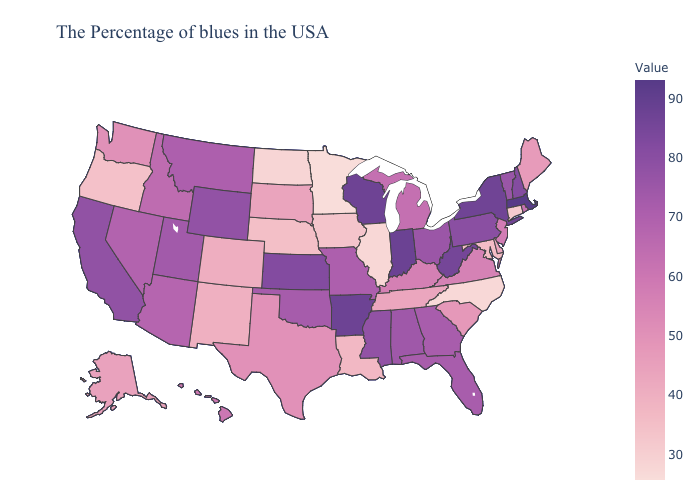Among the states that border Washington , does Oregon have the highest value?
Keep it brief. No. Does the map have missing data?
Quick response, please. No. Among the states that border Colorado , does Nebraska have the lowest value?
Be succinct. Yes. Which states have the lowest value in the South?
Quick response, please. North Carolina. Which states have the lowest value in the Northeast?
Quick response, please. Connecticut. Does Vermont have the highest value in the Northeast?
Answer briefly. No. 